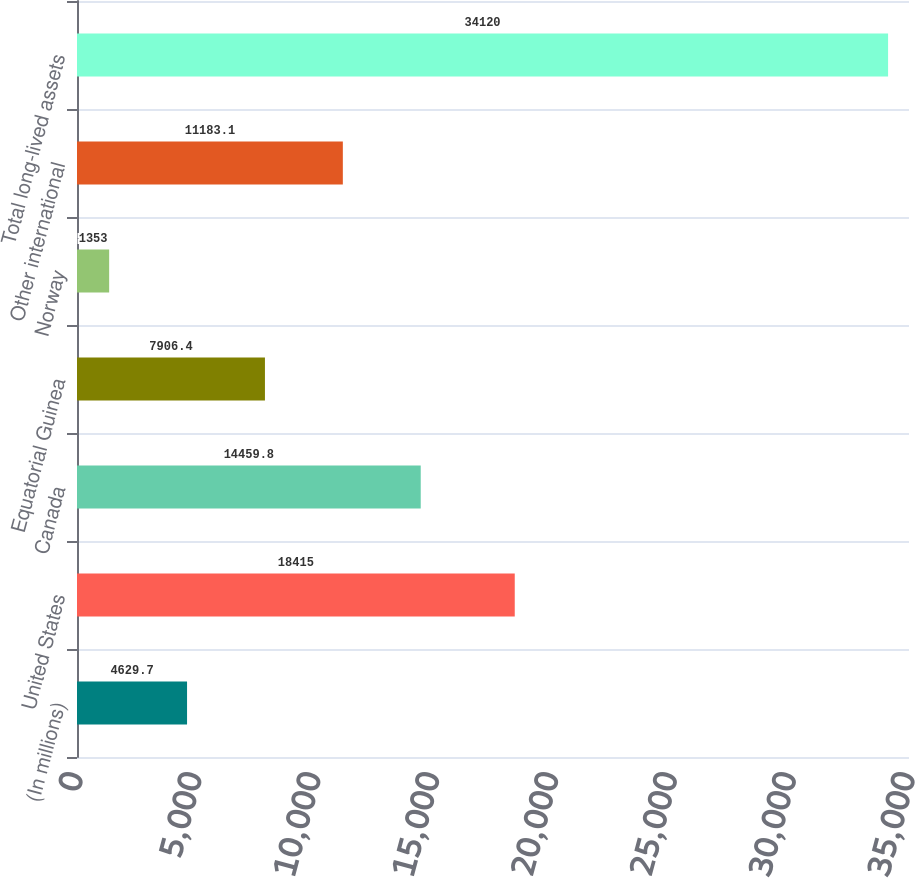Convert chart to OTSL. <chart><loc_0><loc_0><loc_500><loc_500><bar_chart><fcel>(In millions)<fcel>United States<fcel>Canada<fcel>Equatorial Guinea<fcel>Norway<fcel>Other international<fcel>Total long-lived assets<nl><fcel>4629.7<fcel>18415<fcel>14459.8<fcel>7906.4<fcel>1353<fcel>11183.1<fcel>34120<nl></chart> 